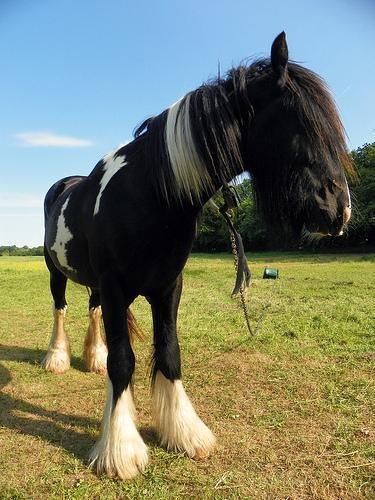How many horse are there?
Give a very brief answer. 1. 